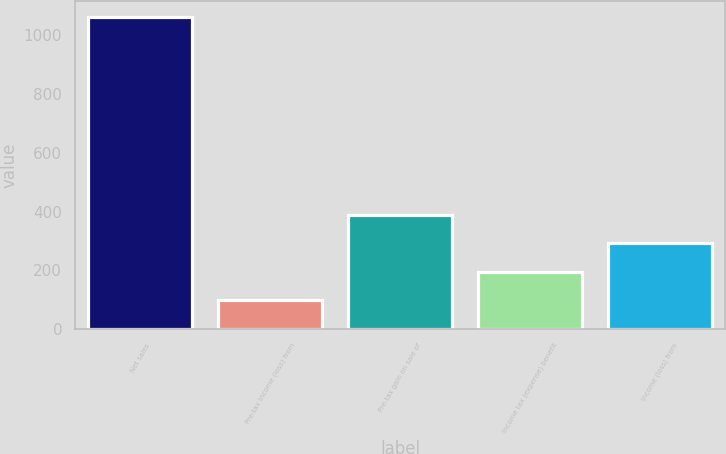<chart> <loc_0><loc_0><loc_500><loc_500><bar_chart><fcel>Net sales<fcel>Pre-tax income (loss) from<fcel>Pre-tax gain on sale of<fcel>Income tax (expense) benefit<fcel>Income (loss) from<nl><fcel>1064<fcel>99<fcel>388.5<fcel>195.5<fcel>292<nl></chart> 